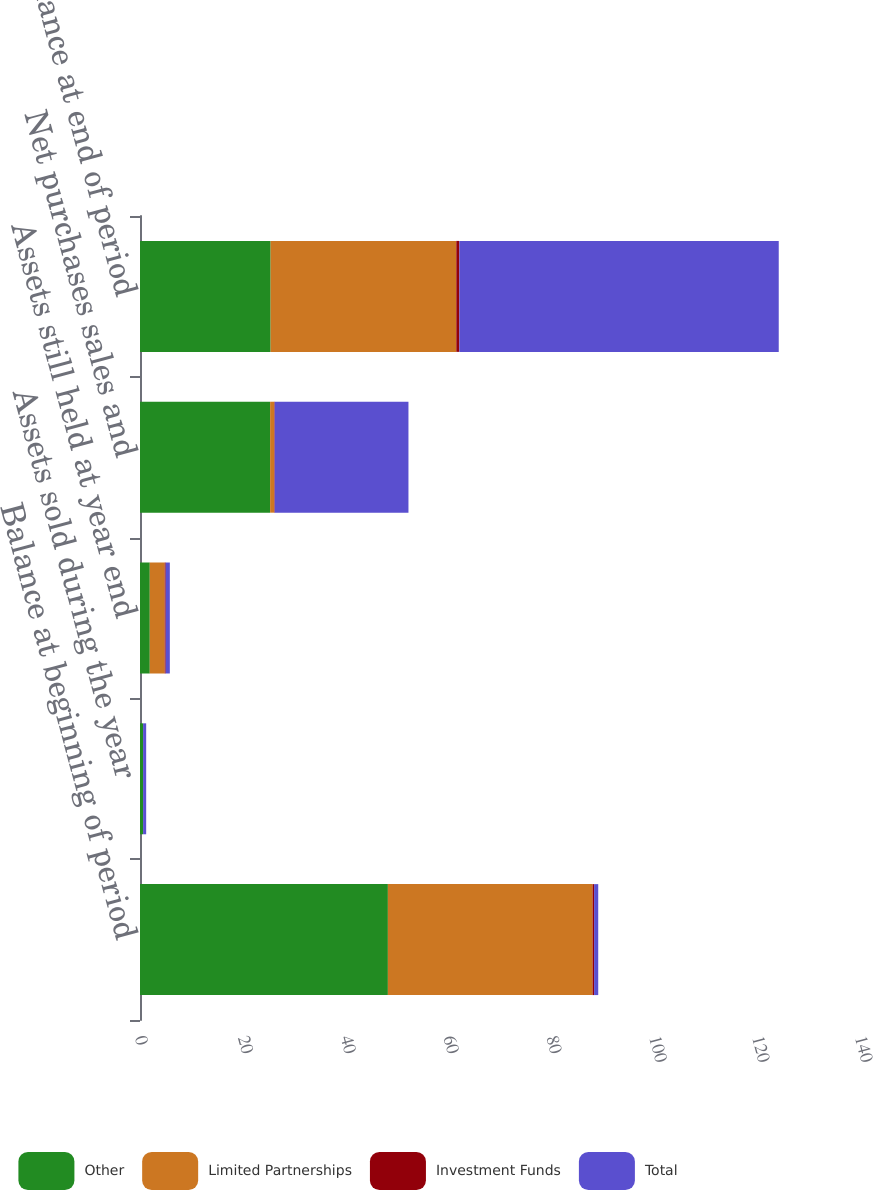<chart> <loc_0><loc_0><loc_500><loc_500><stacked_bar_chart><ecel><fcel>Balance at beginning of period<fcel>Assets sold during the year<fcel>Assets still held at year end<fcel>Net purchases sales and<fcel>Balance at end of period<nl><fcel>Other<fcel>48.2<fcel>0.6<fcel>1.9<fcel>25.3<fcel>25.4<nl><fcel>Limited Partnerships<fcel>39.8<fcel>0<fcel>2.9<fcel>0.8<fcel>36.1<nl><fcel>Investment Funds<fcel>0.3<fcel>0<fcel>0.2<fcel>0.1<fcel>0.6<nl><fcel>Total<fcel>0.8<fcel>0.6<fcel>0.8<fcel>26<fcel>62.1<nl></chart> 